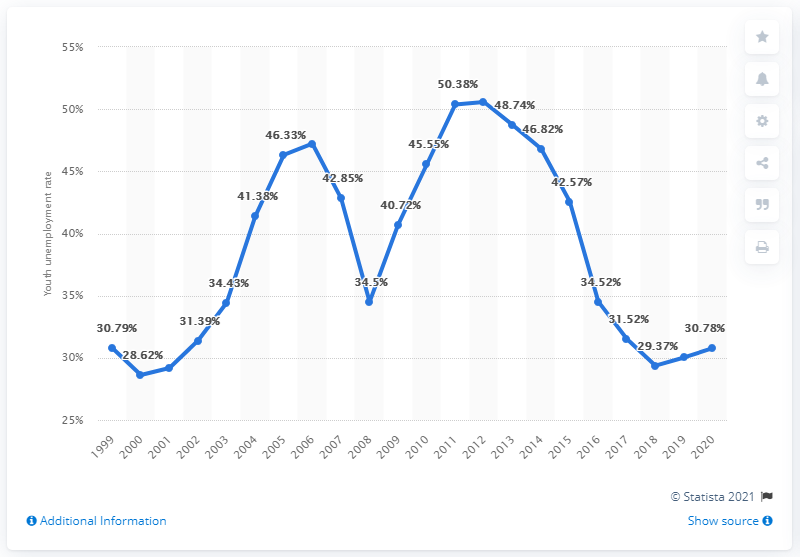Indicate a few pertinent items in this graphic. In 2020, the youth unemployment rate in Serbia was 30.78%. 